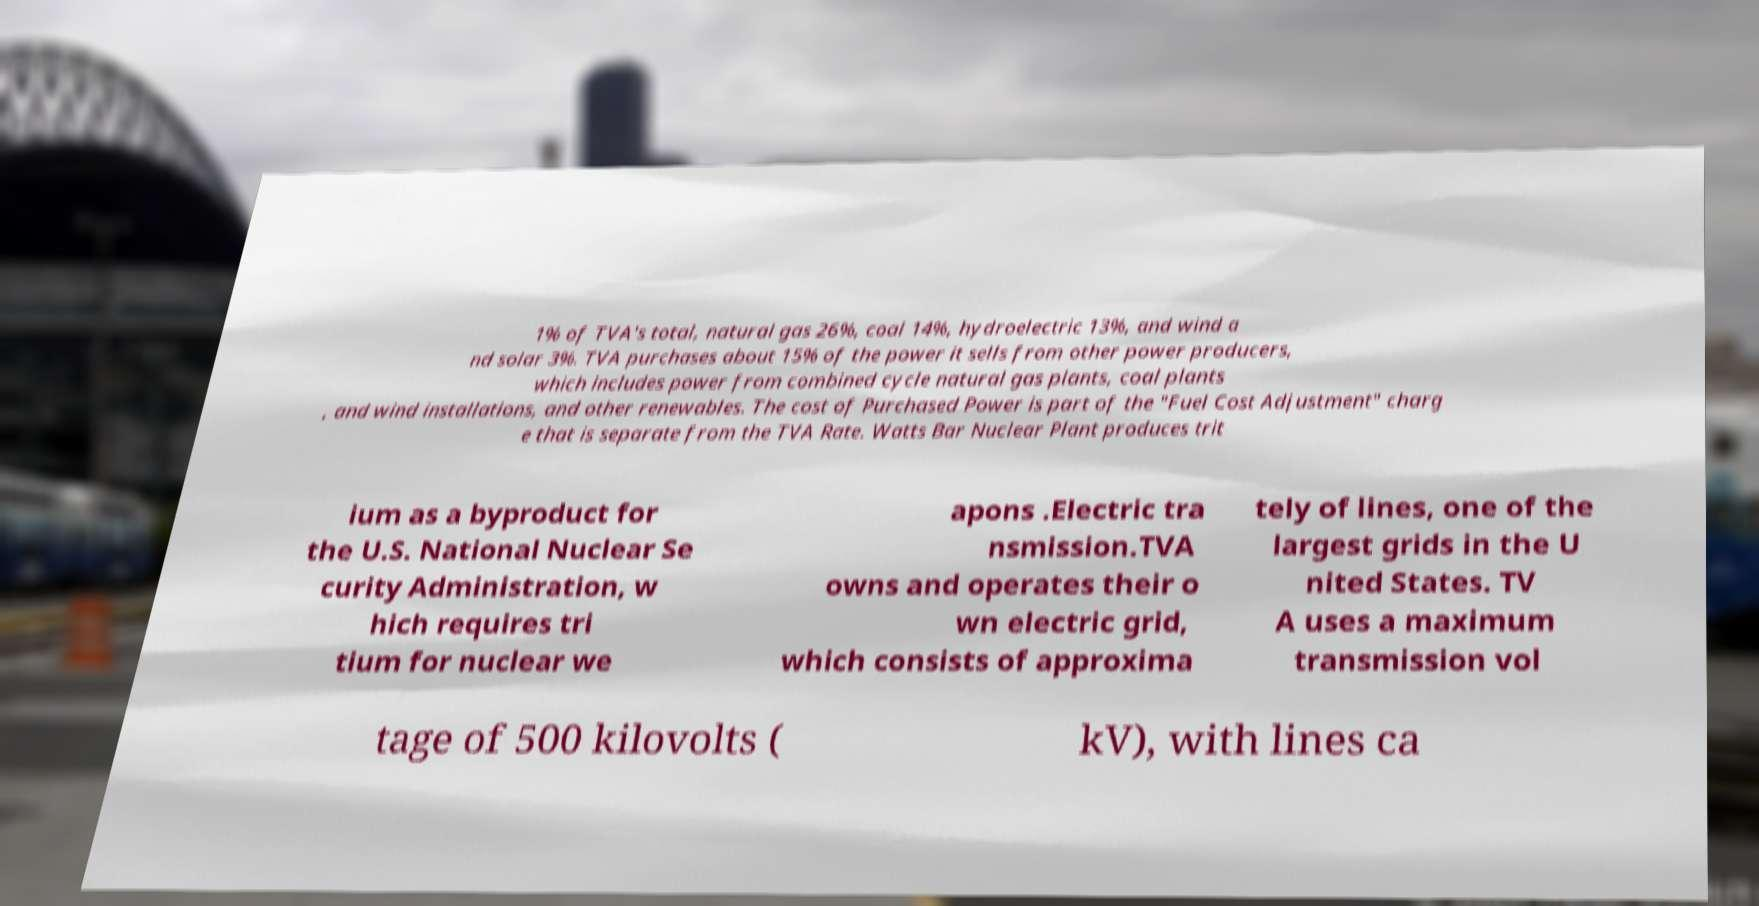I need the written content from this picture converted into text. Can you do that? 1% of TVA's total, natural gas 26%, coal 14%, hydroelectric 13%, and wind a nd solar 3%. TVA purchases about 15% of the power it sells from other power producers, which includes power from combined cycle natural gas plants, coal plants , and wind installations, and other renewables. The cost of Purchased Power is part of the "Fuel Cost Adjustment" charg e that is separate from the TVA Rate. Watts Bar Nuclear Plant produces trit ium as a byproduct for the U.S. National Nuclear Se curity Administration, w hich requires tri tium for nuclear we apons .Electric tra nsmission.TVA owns and operates their o wn electric grid, which consists of approxima tely of lines, one of the largest grids in the U nited States. TV A uses a maximum transmission vol tage of 500 kilovolts ( kV), with lines ca 